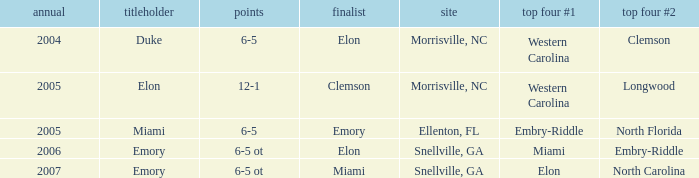How many teams were listed as runner up in 2005 and there the first semi finalist was Western Carolina? 1.0. 